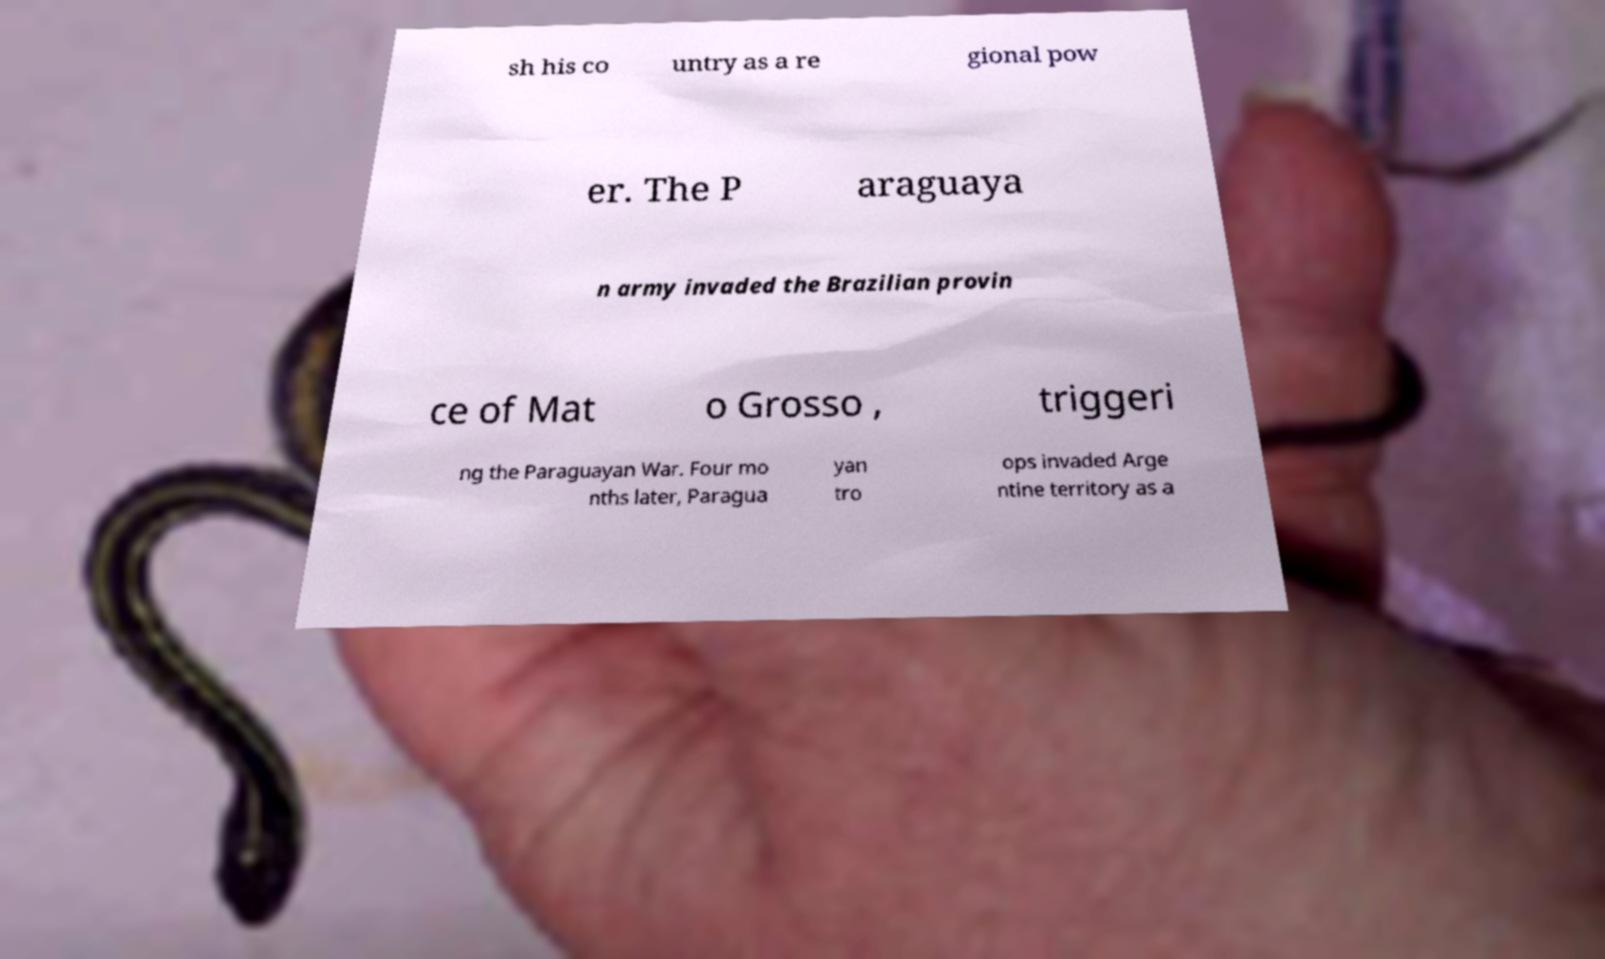Can you read and provide the text displayed in the image?This photo seems to have some interesting text. Can you extract and type it out for me? sh his co untry as a re gional pow er. The P araguaya n army invaded the Brazilian provin ce of Mat o Grosso , triggeri ng the Paraguayan War. Four mo nths later, Paragua yan tro ops invaded Arge ntine territory as a 